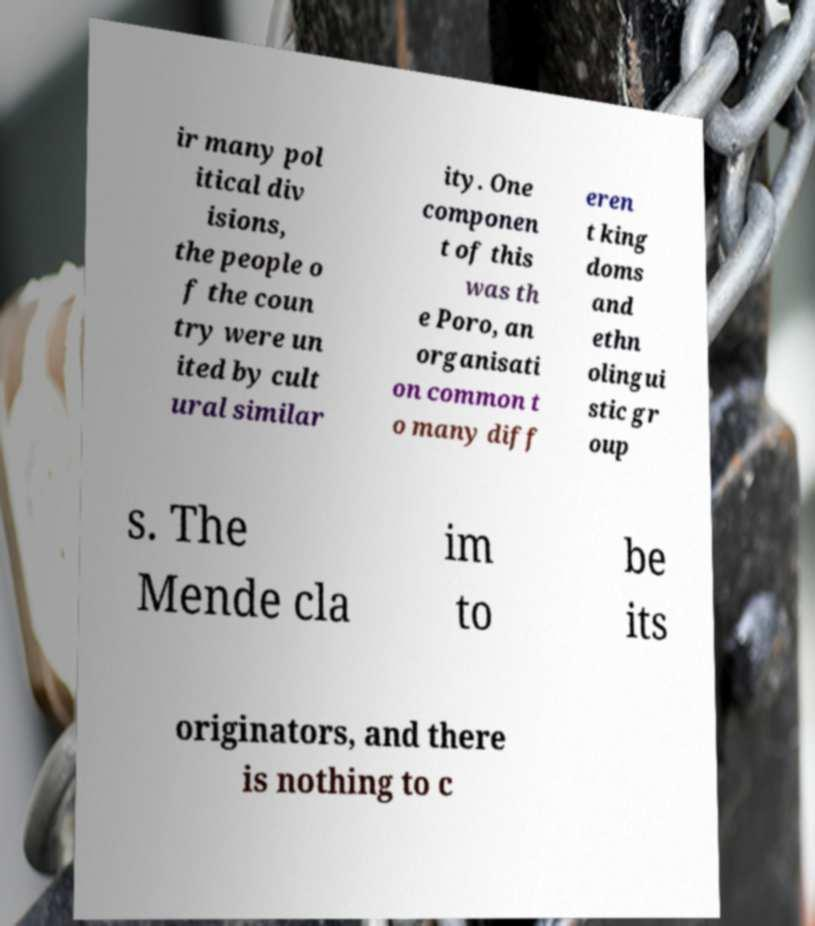Please identify and transcribe the text found in this image. ir many pol itical div isions, the people o f the coun try were un ited by cult ural similar ity. One componen t of this was th e Poro, an organisati on common t o many diff eren t king doms and ethn olingui stic gr oup s. The Mende cla im to be its originators, and there is nothing to c 